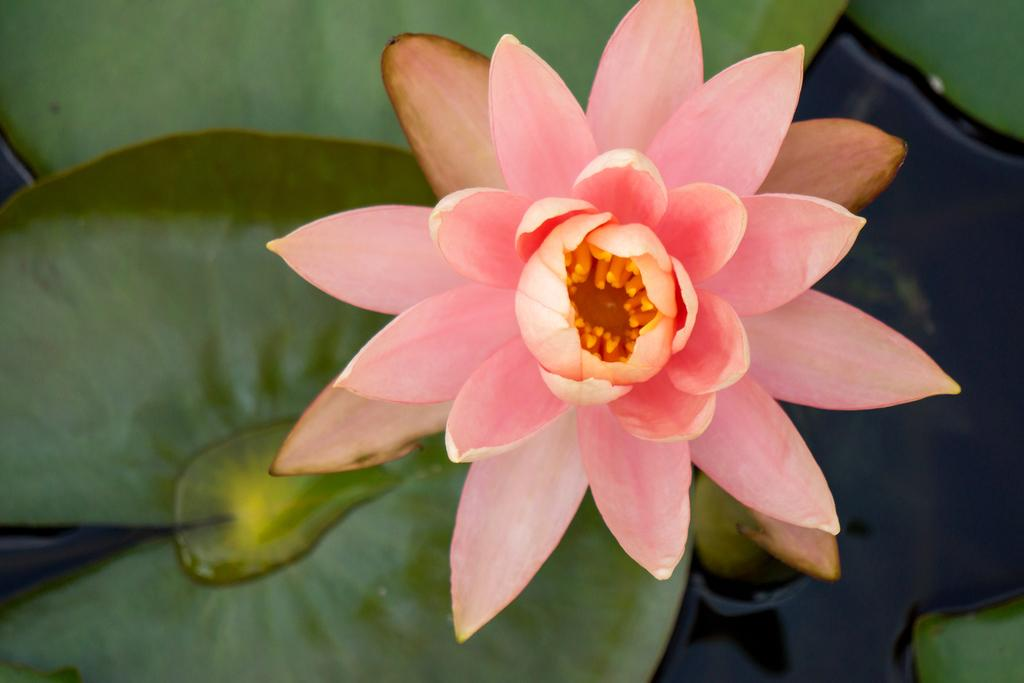What is the main subject in the center of the image? There is a flower in the center of the image. What can be seen at the bottom of the image? There are leaves at the bottom of the image. What else is visible in the image besides the flower and leaves? There is water visible in the image. What type of toys can be seen floating in the water in the image? There are no toys present in the image; it features a flower, leaves, and water. 